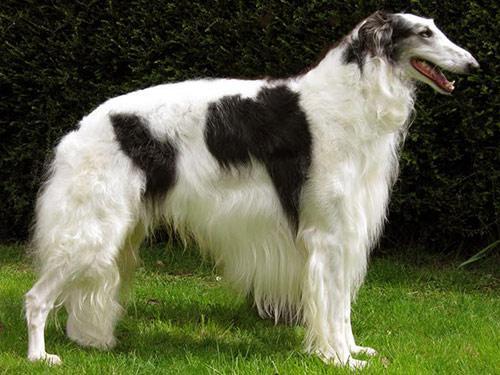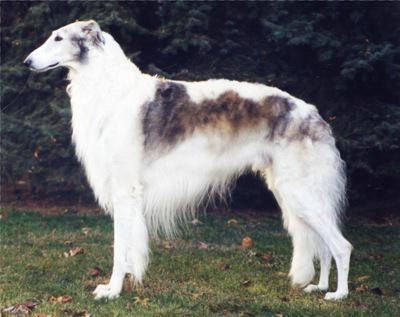The first image is the image on the left, the second image is the image on the right. Evaluate the accuracy of this statement regarding the images: "All dogs in the images are on the grass.". Is it true? Answer yes or no. Yes. 